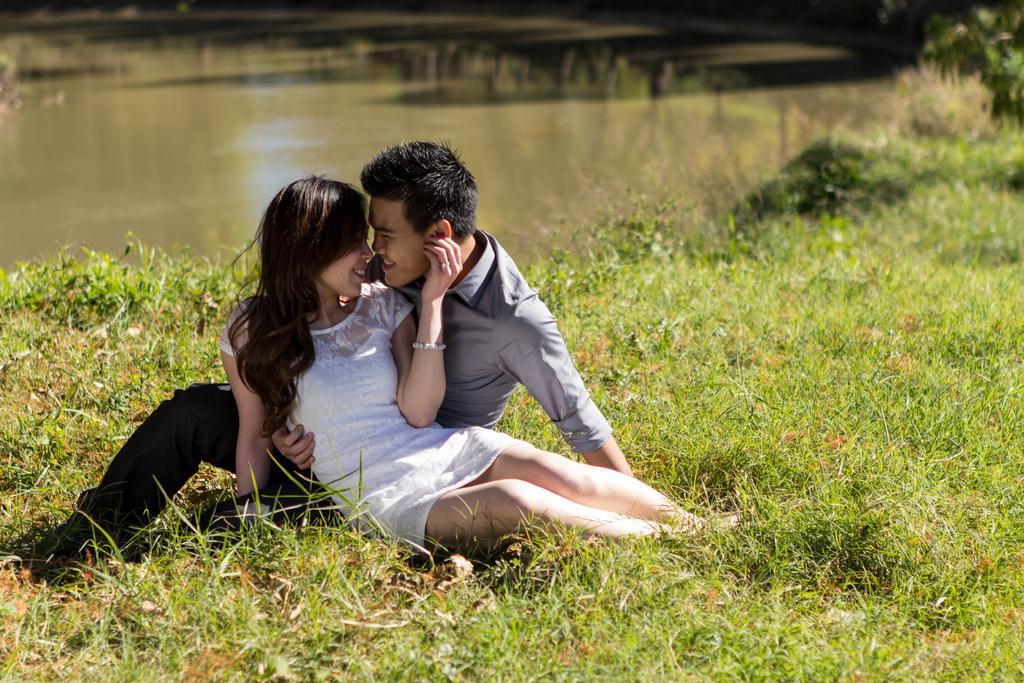How would you summarize this image in a sentence or two? In this image I can see a couple sitting on the grass. In the background, I can see the water. 